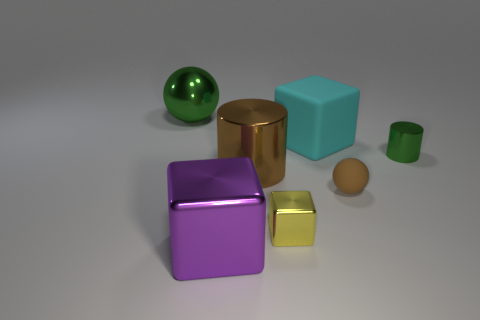The sphere that is the same material as the big cyan block is what size?
Give a very brief answer. Small. What number of objects are either big purple blocks that are in front of the large cyan rubber thing or matte cubes on the right side of the tiny yellow shiny object?
Make the answer very short. 2. There is a green metal object on the left side of the green metallic cylinder; is it the same size as the large purple thing?
Provide a short and direct response. Yes. There is a large block that is in front of the tiny rubber thing; what is its color?
Keep it short and to the point. Purple. There is a tiny metal thing that is the same shape as the big cyan rubber object; what is its color?
Provide a short and direct response. Yellow. How many small yellow things are right of the big metallic object that is on the left side of the big cube in front of the big matte thing?
Offer a very short reply. 1. Are there fewer large purple objects that are to the right of the brown matte ball than shiny cubes?
Keep it short and to the point. Yes. Does the large cylinder have the same color as the rubber sphere?
Give a very brief answer. Yes. What is the size of the green object that is the same shape as the brown metallic object?
Your answer should be very brief. Small. How many other things are made of the same material as the purple object?
Offer a very short reply. 4. 